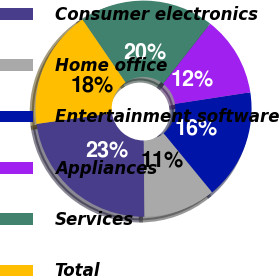Convert chart to OTSL. <chart><loc_0><loc_0><loc_500><loc_500><pie_chart><fcel>Consumer electronics<fcel>Home office<fcel>Entertainment software<fcel>Appliances<fcel>Services<fcel>Total<nl><fcel>22.9%<fcel>10.79%<fcel>16.48%<fcel>12.0%<fcel>20.13%<fcel>17.69%<nl></chart> 